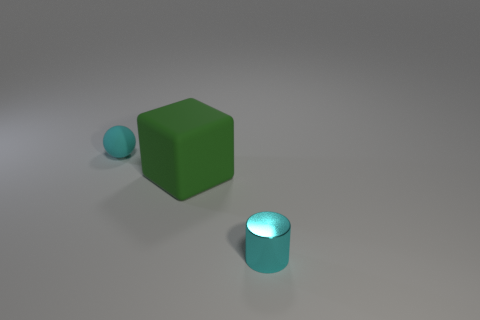Are there any other things that have the same size as the matte cube?
Provide a succinct answer. No. There is a object that is both behind the cyan metal cylinder and in front of the cyan matte ball; what size is it?
Provide a short and direct response. Large. How many cyan rubber spheres are the same size as the green matte block?
Provide a succinct answer. 0. How many big green blocks are in front of the cyan object on the right side of the cyan ball?
Your answer should be very brief. 0. There is a ball that is on the left side of the tiny metal cylinder; is it the same color as the tiny metallic thing?
Your response must be concise. Yes. Is there a small cyan cylinder that is on the left side of the cyan thing that is on the left side of the cyan thing in front of the tiny sphere?
Give a very brief answer. No. What shape is the object that is to the right of the tiny cyan ball and to the left of the metallic object?
Make the answer very short. Cube. Is there a small cylinder of the same color as the small matte object?
Offer a very short reply. Yes. There is a small thing that is to the left of the cyan object that is to the right of the matte sphere; what is its color?
Provide a succinct answer. Cyan. What is the size of the cyan thing behind the cyan object to the right of the sphere that is left of the cube?
Your answer should be very brief. Small. 